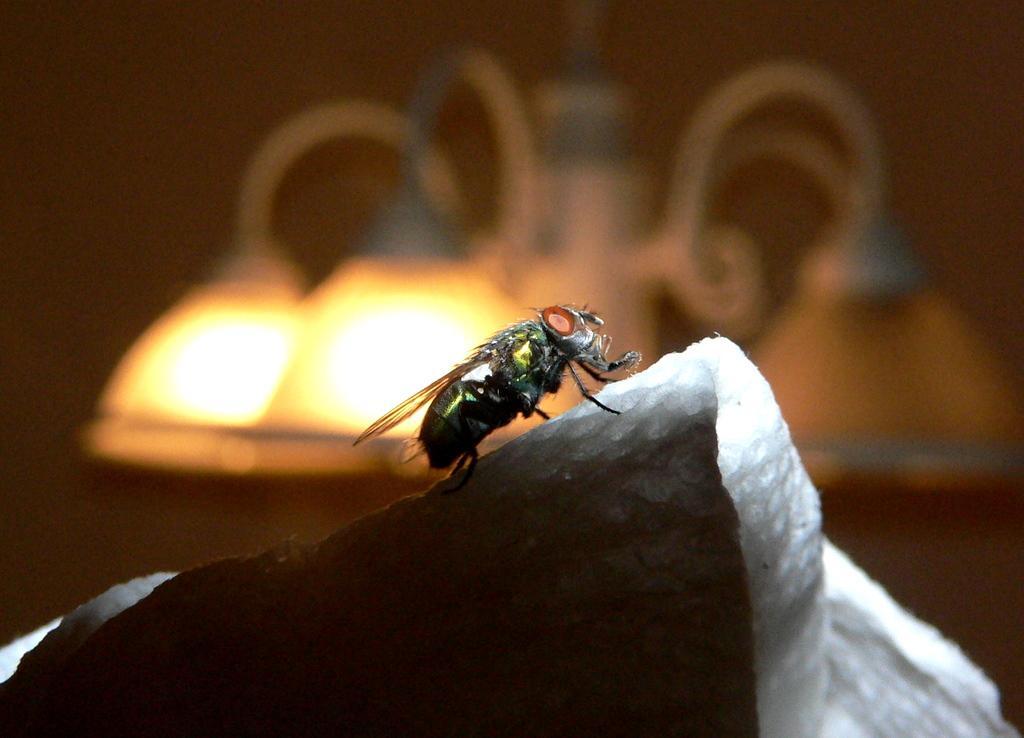Describe this image in one or two sentences. This image is taken indoors. In this image the background is a little blurred and there is a light. At the bottom of the image there is a tissue paper. In the middle of the image there is a fly on the tissue paper. 